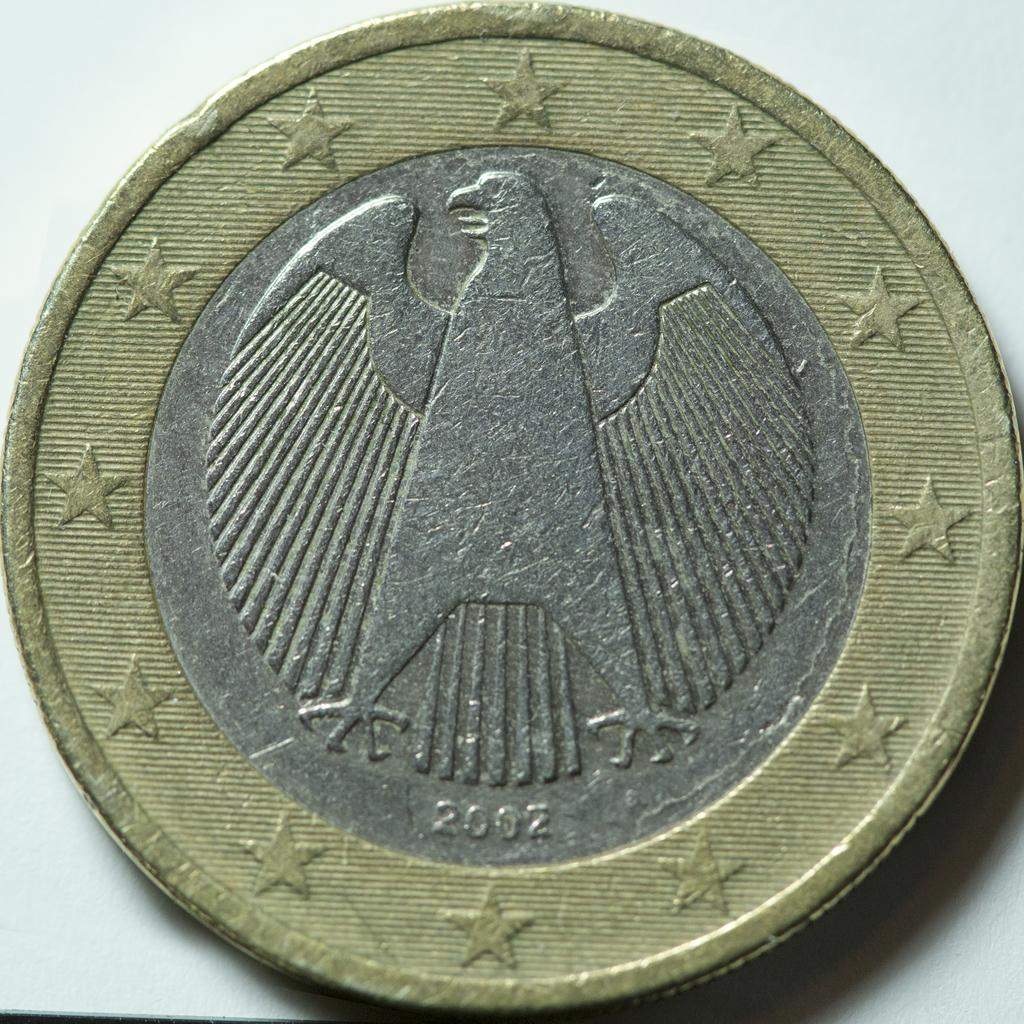<image>
Offer a succinct explanation of the picture presented. A coin with an eagle on it was minted in the year 2002. 